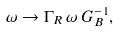<formula> <loc_0><loc_0><loc_500><loc_500>\omega \to \Gamma _ { R } \, \omega \, G ^ { - 1 } _ { B } ,</formula> 